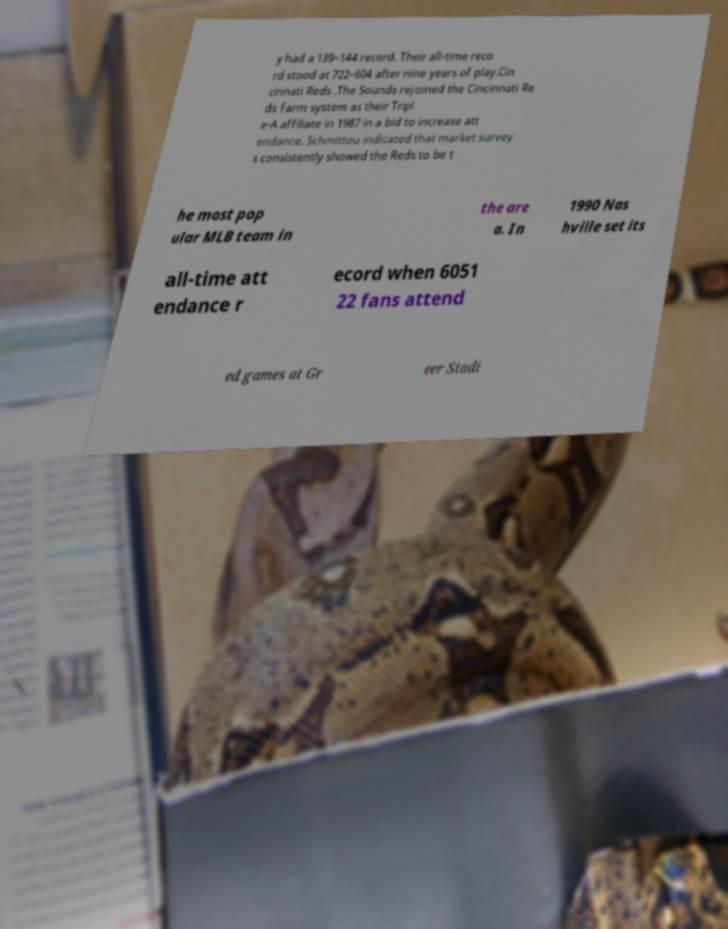Can you accurately transcribe the text from the provided image for me? y had a 139–144 record. Their all-time reco rd stood at 722–604 after nine years of play.Cin cinnati Reds .The Sounds rejoined the Cincinnati Re ds farm system as their Tripl e-A affiliate in 1987 in a bid to increase att endance. Schmittou indicated that market survey s consistently showed the Reds to be t he most pop ular MLB team in the are a. In 1990 Nas hville set its all-time att endance r ecord when 6051 22 fans attend ed games at Gr eer Stadi 